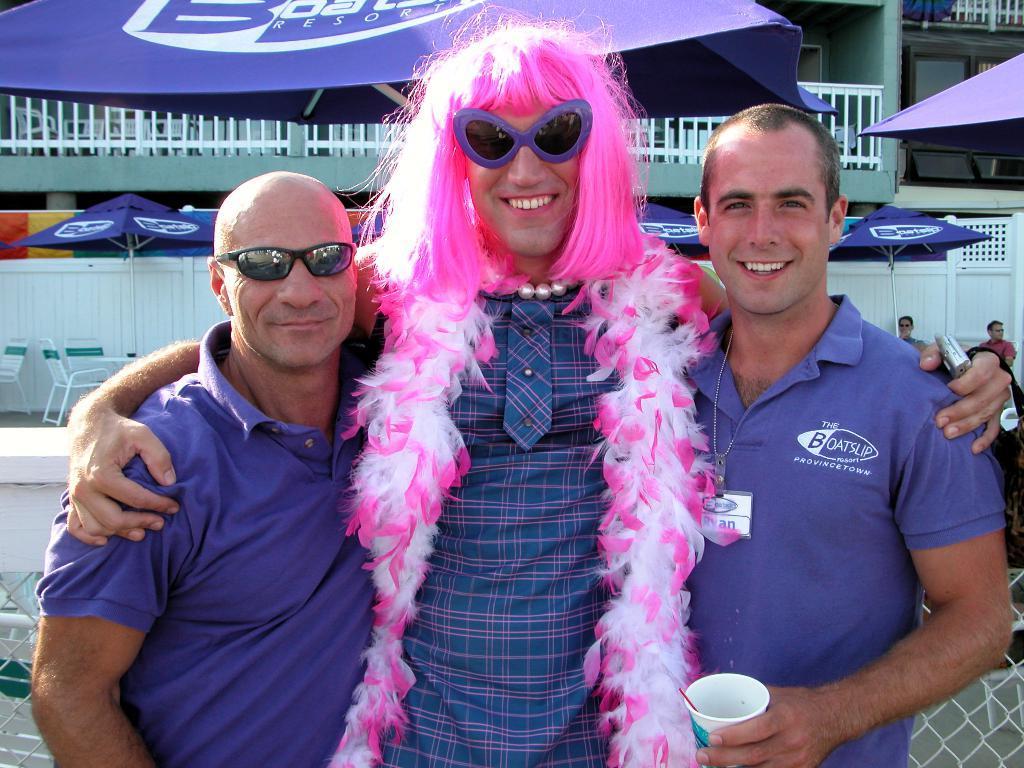Can you describe this image briefly? In the foreground of the picture I can see three men and there is a smile on their faces. I can see a man on the right side is wearing a T-shirt and he is holding a glass in his left hand. There is a man in the middle of the picture and he is holding a mobile phone in his left hand. I can see a pink color hair and scarf. In the background, I can see the tents, chairs and a metal fence. I can see two men on the right side. 